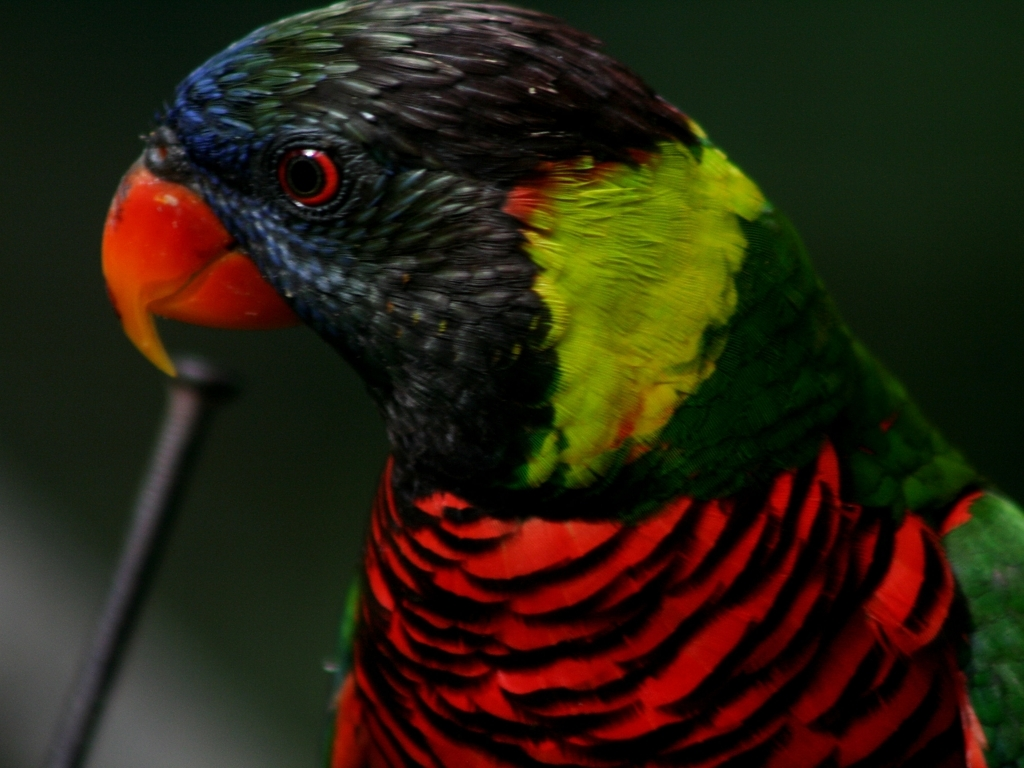Why is the quality of this image acceptable? The image's quality is acceptable due to the clear depiction of the subject, a parrot, with richly colored feathers that maintain a level of detail, although there is some slight blurriness in the background. This balance of color vibrancy and focus draws the viewer's attention to the parrot itself, which is the main subject of the photograph. 